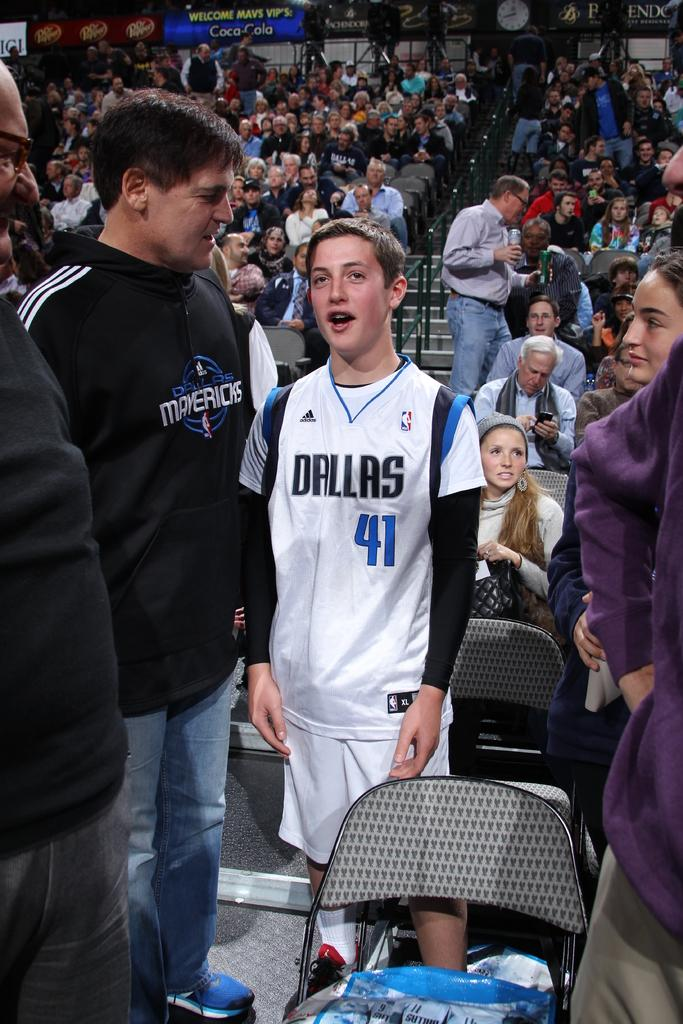<image>
Create a compact narrative representing the image presented. A young man with dallas and 41 on his white top appears to have to say something amongst watching people. 